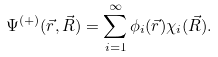<formula> <loc_0><loc_0><loc_500><loc_500>\Psi ^ { ( + ) } ( \vec { r } , \vec { R } ) = \sum _ { i = 1 } ^ { \infty } \phi _ { i } ( \vec { r } ) \chi _ { i } ( \vec { R } ) .</formula> 